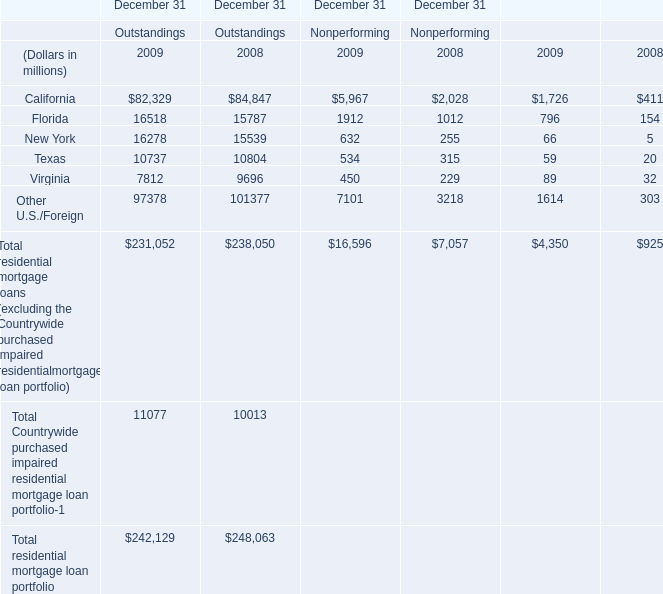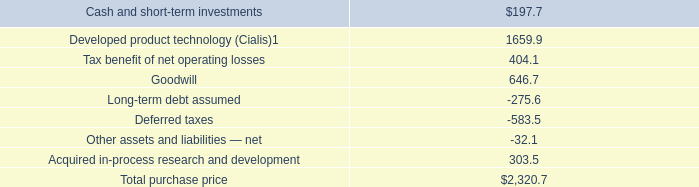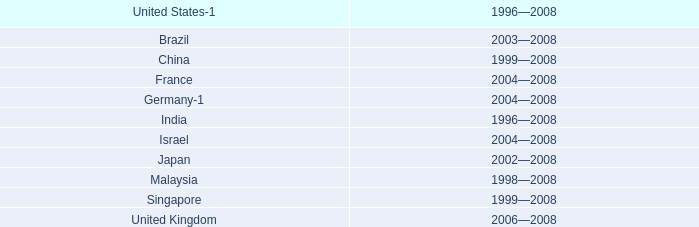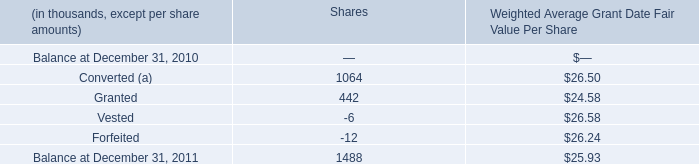What's the average of Balance at December 31, 2011 of Shares —, and New York of December 31 Outstandings 2009 ? 
Computations: ((1488.0 + 16278.0) / 2)
Answer: 8883.0. 